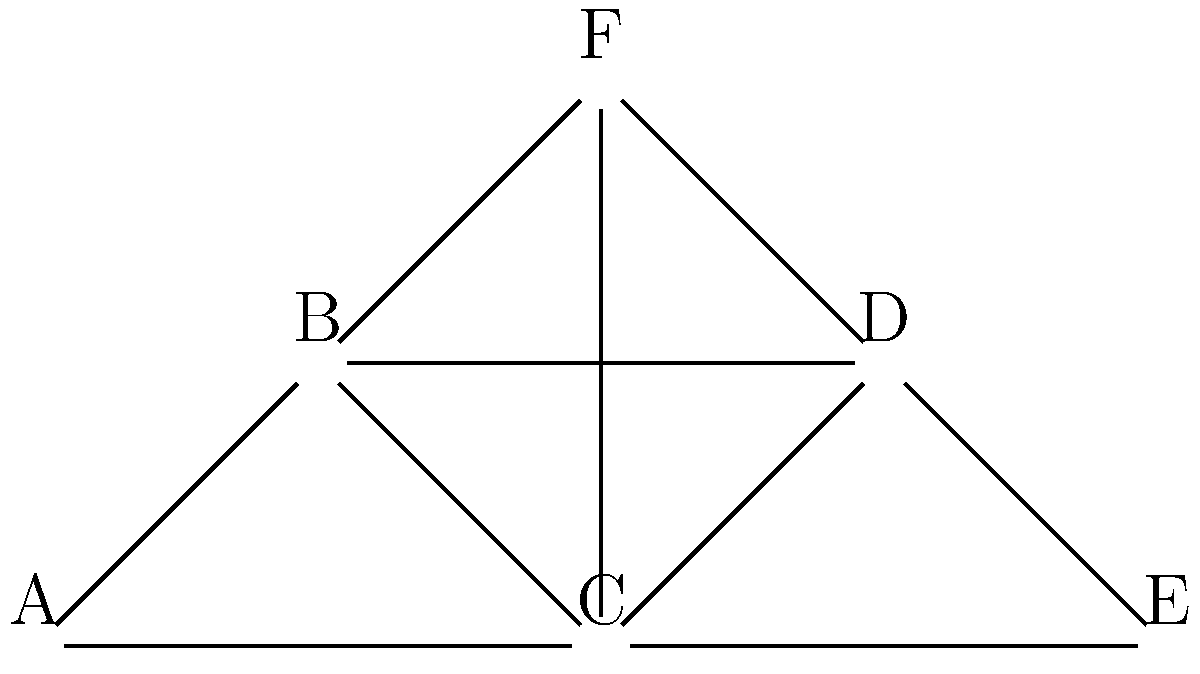In the utility grid represented by the node-link diagram above, which node(s) would be considered the most critical for maintaining overall connectivity? Assume that the removal of a critical node would disconnect the largest number of other nodes from the network. To identify the most critical node(s) in this utility grid, we need to analyze the impact of removing each node:

1. Node A: Removing A would disconnect only itself from the network.
2. Node B: Removing B would disconnect A and F from the rest of the network.
3. Node C: Removing C would disconnect the network into two components: {A, B, F} and {D, E}.
4. Node D: Removing D would disconnect E from the rest of the network.
5. Node E: Removing E would disconnect only itself from the network.
6. Node F: Removing F would disconnect only itself from the network.

The node whose removal would disconnect the largest number of other nodes is Node C. It acts as a bridge between two major parts of the network. Removing C would split the network into two disconnected components, affecting the largest number of nodes.

In graph theory, such a node is often referred to as an articulation point or a cut vertex. Its removal increases the number of connected components in the graph.
Answer: Node C 